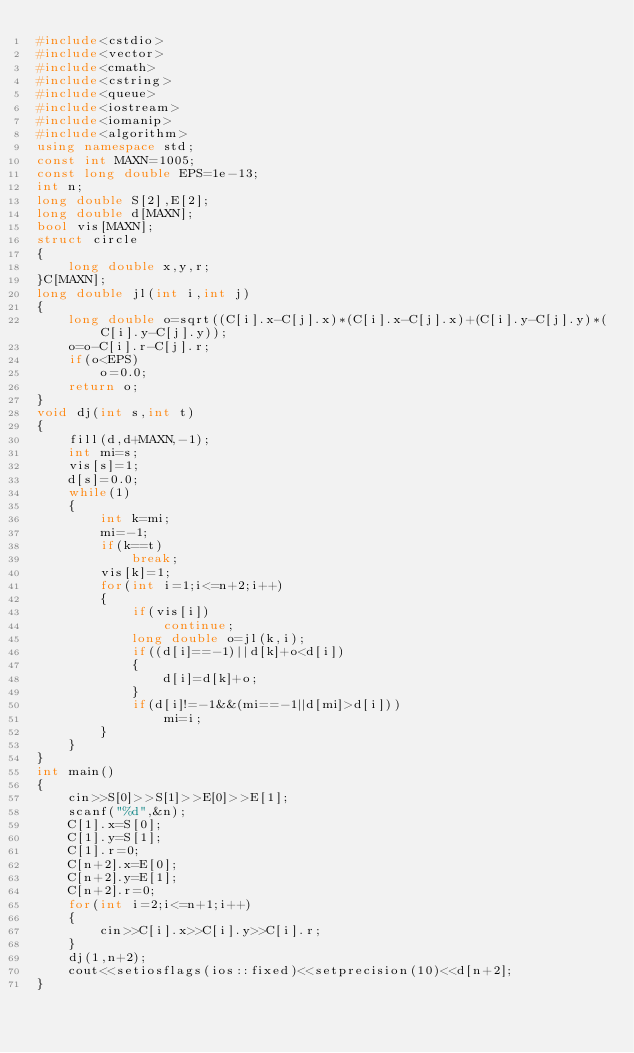Convert code to text. <code><loc_0><loc_0><loc_500><loc_500><_C++_>#include<cstdio>
#include<vector>
#include<cmath>
#include<cstring>
#include<queue>
#include<iostream>
#include<iomanip>
#include<algorithm>
using namespace std;
const int MAXN=1005;
const long double EPS=1e-13;
int n;
long double S[2],E[2];
long double d[MAXN];
bool vis[MAXN];
struct circle
{
	long double x,y,r;
}C[MAXN];
long double jl(int i,int j)
{
	long double o=sqrt((C[i].x-C[j].x)*(C[i].x-C[j].x)+(C[i].y-C[j].y)*(C[i].y-C[j].y));
	o=o-C[i].r-C[j].r;
	if(o<EPS)
		o=0.0;
	return o;
}
void dj(int s,int t)
{
	fill(d,d+MAXN,-1);
	int mi=s;
	vis[s]=1;
	d[s]=0.0;
	while(1)
	{
		int k=mi;
		mi=-1;
		if(k==t)
			break;
		vis[k]=1;
		for(int i=1;i<=n+2;i++)
		{
			if(vis[i])
				continue;
			long double o=jl(k,i);
			if((d[i]==-1)||d[k]+o<d[i])
			{
				d[i]=d[k]+o;
			}
			if(d[i]!=-1&&(mi==-1||d[mi]>d[i]))
				mi=i;
		}
	}
}
int main()
{
	cin>>S[0]>>S[1]>>E[0]>>E[1];
	scanf("%d",&n);
	C[1].x=S[0];
	C[1].y=S[1];
	C[1].r=0;
	C[n+2].x=E[0];
	C[n+2].y=E[1];
	C[n+2].r=0;
	for(int i=2;i<=n+1;i++)
	{
		cin>>C[i].x>>C[i].y>>C[i].r;
	}
	dj(1,n+2);
	cout<<setiosflags(ios::fixed)<<setprecision(10)<<d[n+2];
}</code> 